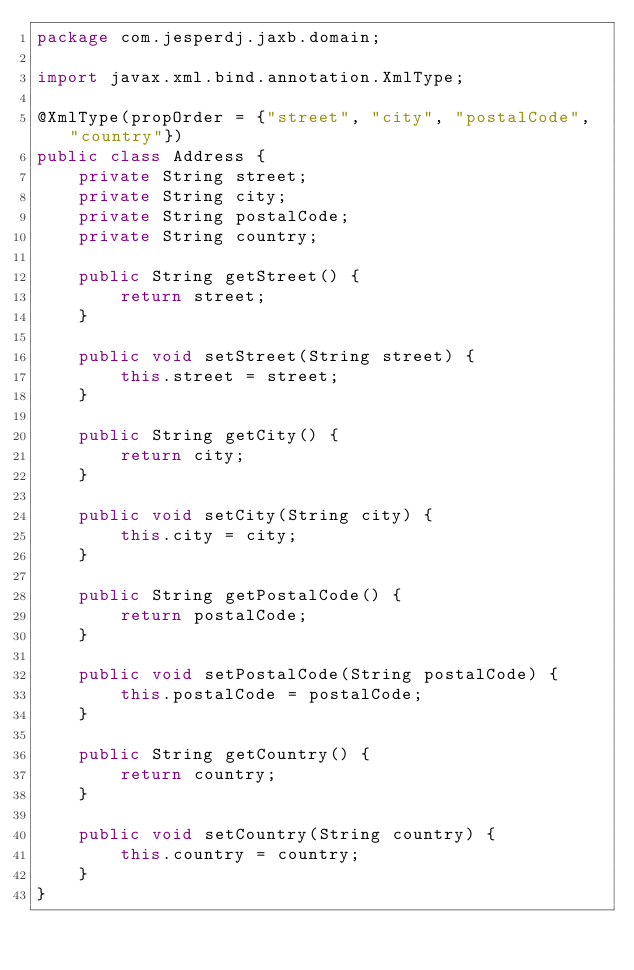Convert code to text. <code><loc_0><loc_0><loc_500><loc_500><_Java_>package com.jesperdj.jaxb.domain;

import javax.xml.bind.annotation.XmlType;

@XmlType(propOrder = {"street", "city", "postalCode", "country"})
public class Address {
    private String street;
    private String city;
    private String postalCode;
    private String country;

    public String getStreet() {
        return street;
    }

    public void setStreet(String street) {
        this.street = street;
    }

    public String getCity() {
        return city;
    }

    public void setCity(String city) {
        this.city = city;
    }

    public String getPostalCode() {
        return postalCode;
    }

    public void setPostalCode(String postalCode) {
        this.postalCode = postalCode;
    }

    public String getCountry() {
        return country;
    }

    public void setCountry(String country) {
        this.country = country;
    }
}
</code> 